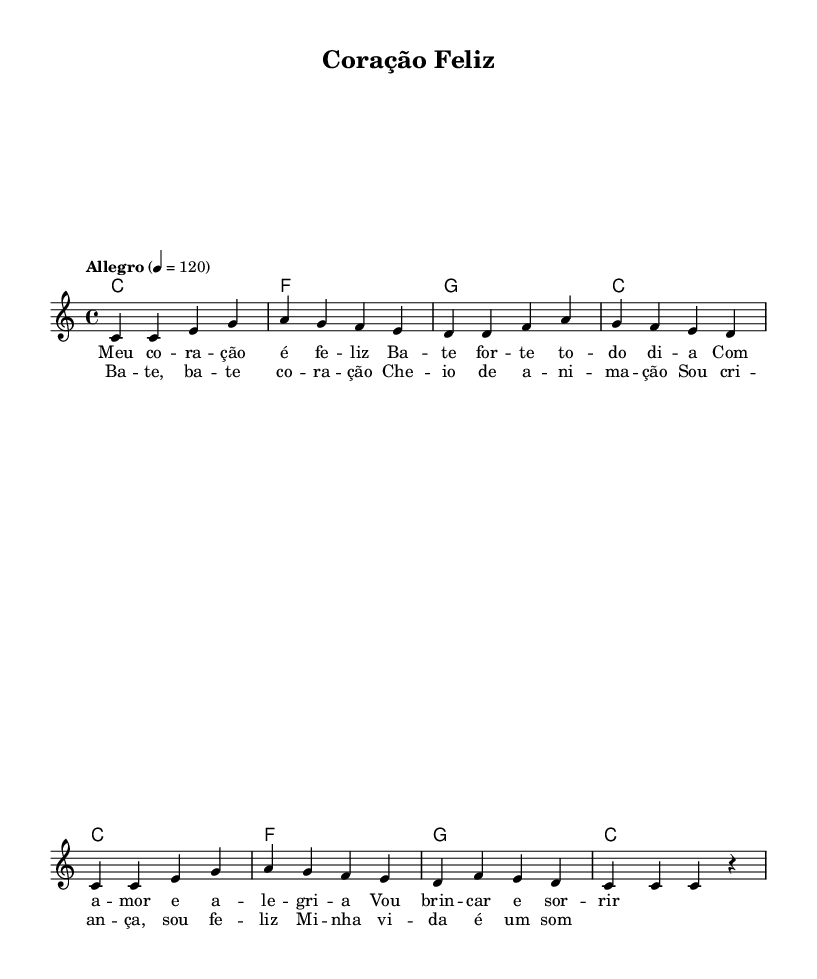What is the key signature of this music? The key signature is indicated in the global section, and it shows C major, which has no sharps or flats.
Answer: C major What is the time signature of this piece? The time signature can be found in the global section, which states 4/4. This means there are four beats per measure.
Answer: 4/4 What is the tempo marking for this music? The tempo marking is located in the global section and indicates "Allegro," with a metronome marking of 120, suggesting a fast pace.
Answer: Allegro How many measures are there in the melody? By counting the groups of notes and the bar lines in the melody section, there are a total of 8 measures.
Answer: 8 What is the first word of the verse? The first word of the verse appears at the start of the lyric section for the melody, and it is "Meu".
Answer: Meu How many different chords are used? The chord section shows that there are four different chords listed: C, F, and G. Counting these gives a total of 3 unique chords.
Answer: 3 What is the theme of the song based on the lyrics? The lyrics express themes of happiness and playfulness through phrases like "Meu coração é feliz" and mentions of joy and fun, indicating a cheerful children’s song.
Answer: Happiness 